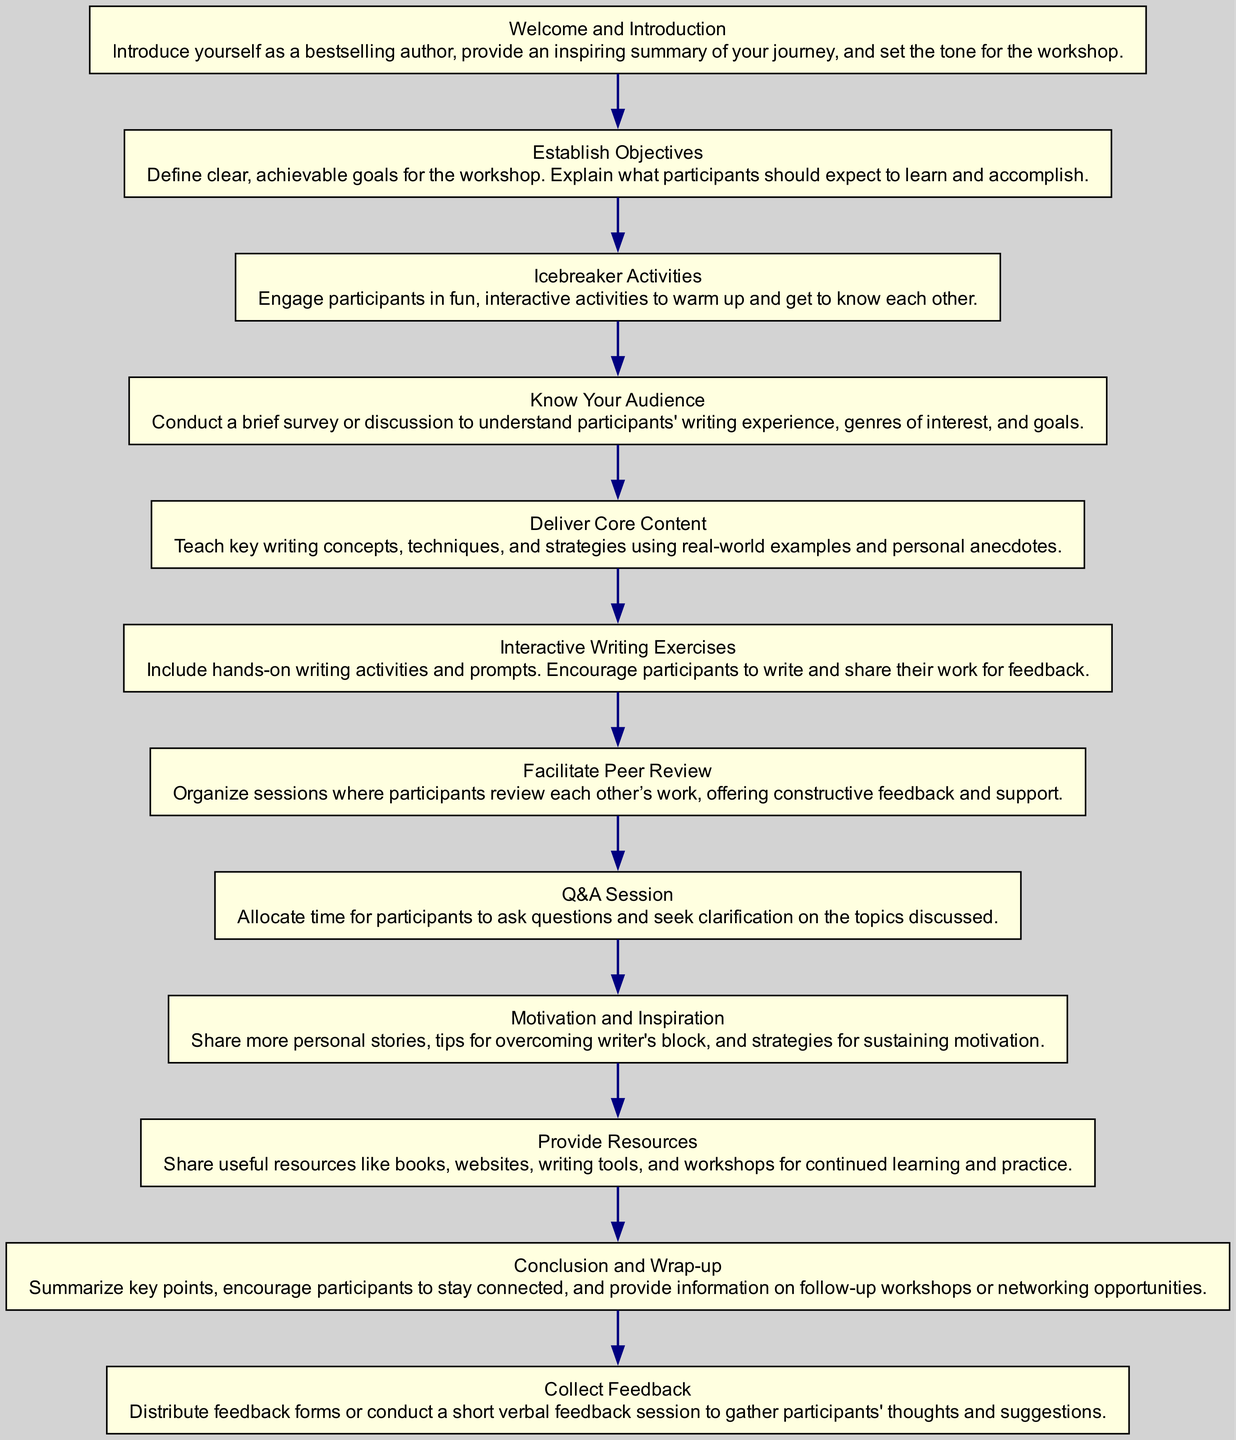What is the first step in the workshop structure? The diagram indicates that the first step is "Welcome and Introduction," where the instructor introduces themselves and sets the tone for the workshop.
Answer: Welcome and Introduction How many main stages are in the flow chart? By counting the nodes in the diagram, there are eleven main stages outlined, from the introduction to feedback collection.
Answer: Eleven What comes after the Icebreaker Activities? Following the Icebreaker Activities in the flow chart, the next step is "Know Your Audience," which focuses on understanding participants’ backgrounds and goals.
Answer: Know Your Audience Which stage focuses on providing constructive feedback? The "Facilitate Peer Review" stage emphasizes organizing opportunities for participants to review and critique one another's work.
Answer: Facilitate Peer Review What are the last two stages of the workshop? The last two stages, as per the diagram, are "Collect Feedback" and "Conclusion and Wrap-up," focusing on gathering participants' thoughts and summarizing key points.
Answer: Collect Feedback and Conclusion and Wrap-up How does the "Motivation and Inspiration" stage relate to the "Interactive Writing Exercises"? The "Motivation and Inspiration" stage does not directly lead to "Interactive Writing Exercises," but they are connected as both aim to enhance participants' engagement and writing efforts throughout the workshop.
Answer: Indirectly connected What is the primary goal of the "Establish Objectives" step? The primary goal of this step is to define clear, achievable goals for the workshop to set expectations for participants.
Answer: Define clear, achievable goals Which stage allows for questions about content discussed in the workshop? The "Q&A Session" is designated for participants to ask questions related to the content covered during the workshop.
Answer: Q&A Session What is intended by the "Provide Resources" stage? The "Provide Resources" stage aims to share useful tools and materials for continued learning and improvement in writing outside the workshop.
Answer: Share useful resources 